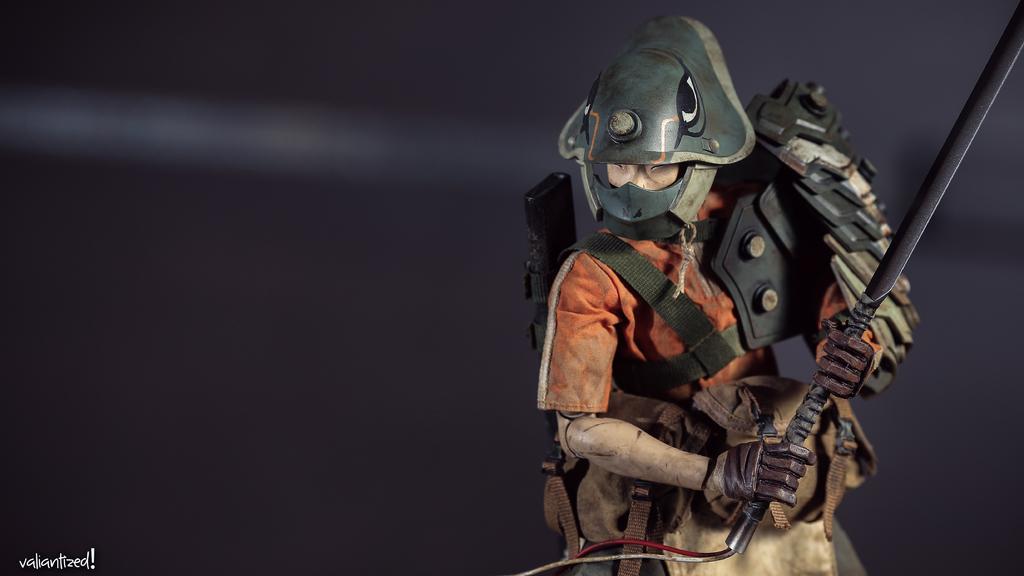Could you give a brief overview of what you see in this image? In this picture we can observe a toy holding a sword. We can observe helmet and an orange color shirt. The background is in black color. We can observe text on the left side. 